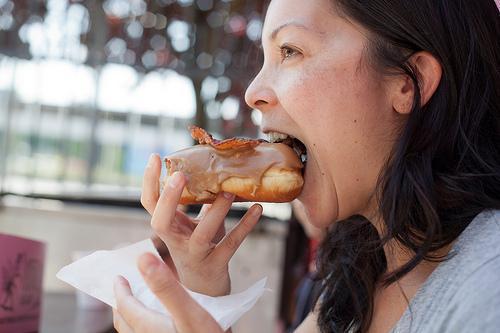How many donuts does the woman have?
Give a very brief answer. 1. 